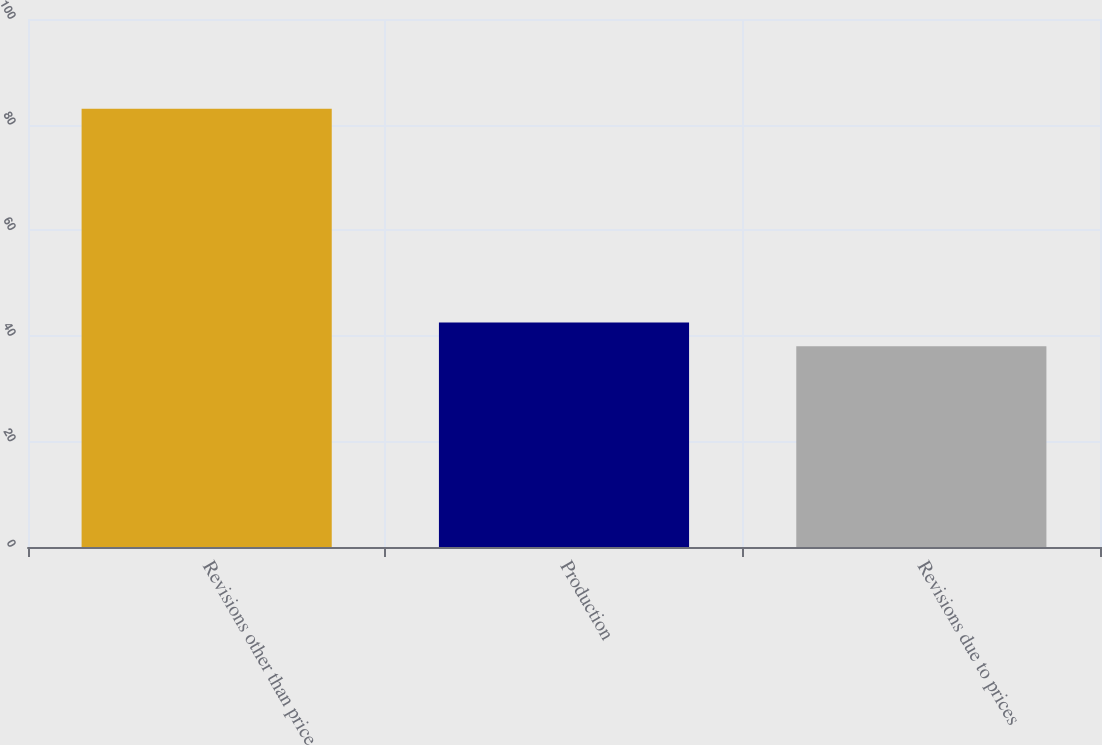Convert chart to OTSL. <chart><loc_0><loc_0><loc_500><loc_500><bar_chart><fcel>Revisions other than price<fcel>Production<fcel>Revisions due to prices<nl><fcel>83<fcel>42.5<fcel>38<nl></chart> 